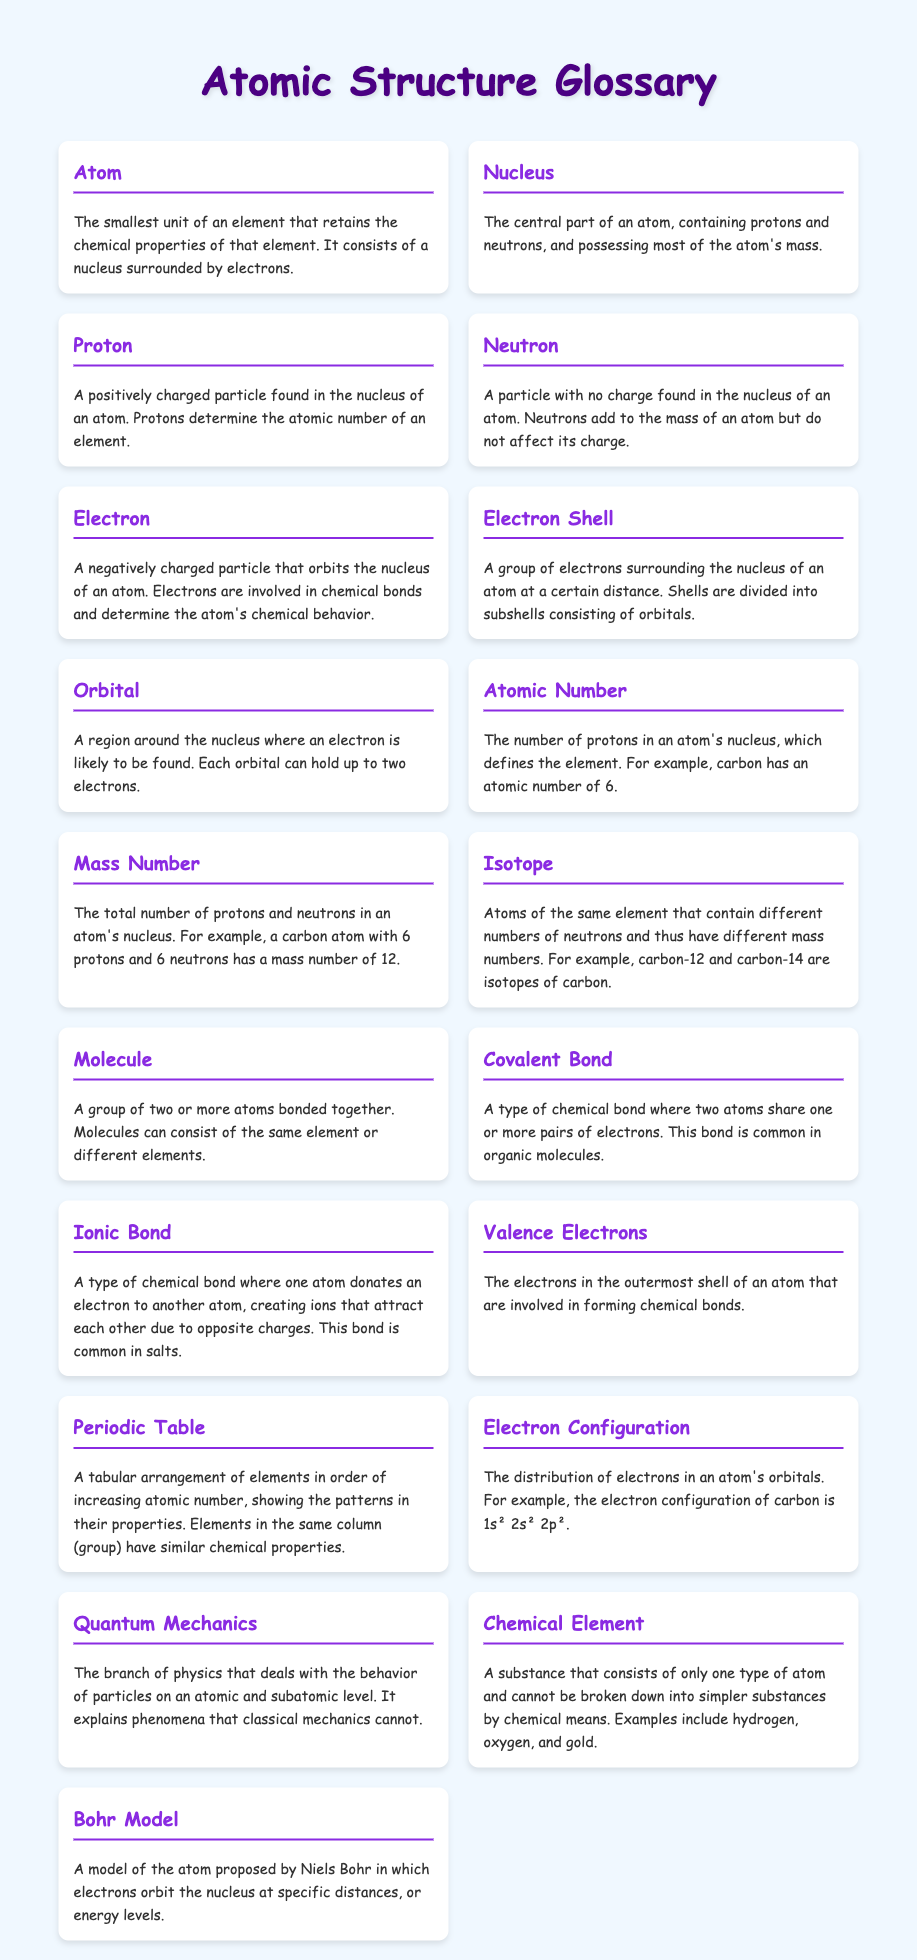What is the smallest unit of an element? An atom is defined as the smallest unit of an element that retains the chemical properties of that element.
Answer: Atom What determines the atomic number of an element? The atomic number is determined by the number of protons in an atom's nucleus.
Answer: Protons What are atoms with different numbers of neutrons called? Atoms that contain different numbers of neutrons but are of the same element are called isotopes.
Answer: Isotope What is the term for a group of two or more atoms bonded together? A group of two or more atoms that are bonded together is called a molecule.
Answer: Molecule How many electrons can an orbital hold? Each orbital can hold a maximum of two electrons.
Answer: Two 